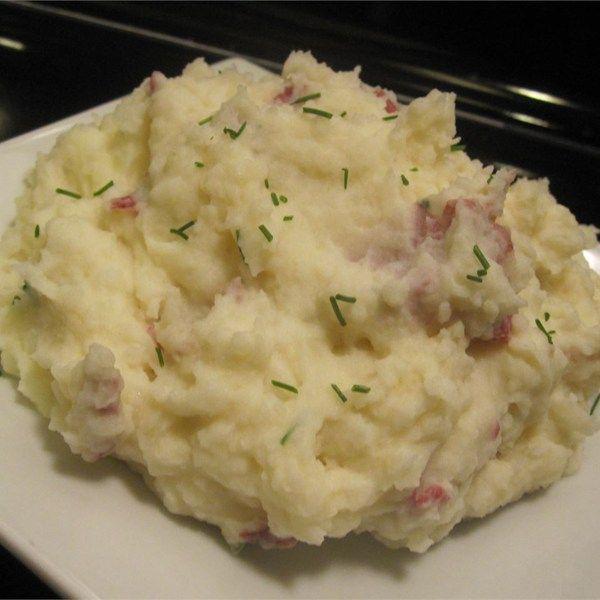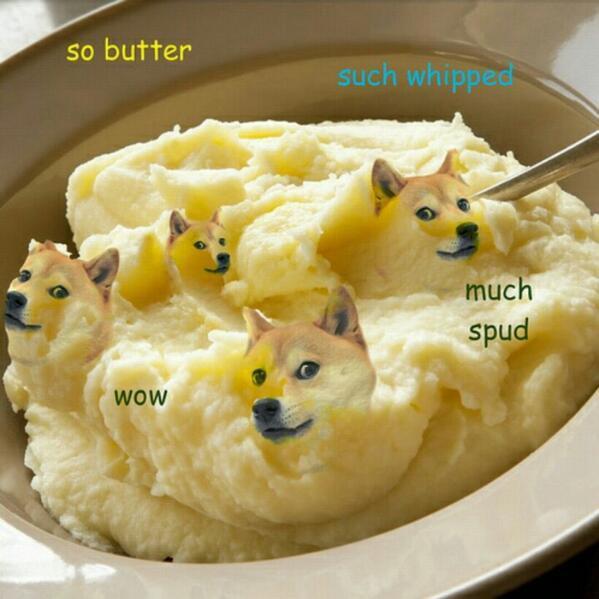The first image is the image on the left, the second image is the image on the right. Assess this claim about the two images: "The food in the image on the left is sitting in a brown plate.". Correct or not? Answer yes or no. No. The first image is the image on the left, the second image is the image on the right. Given the left and right images, does the statement "One of the mashed potato dishes does not contain chives." hold true? Answer yes or no. Yes. 